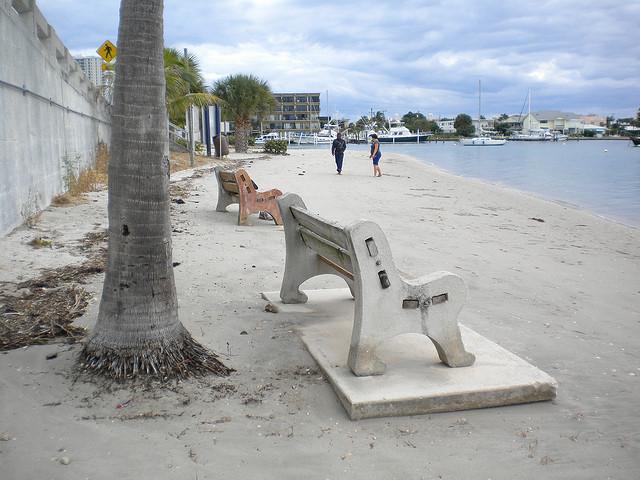Is there a television here?
Keep it brief. No. Is it a cold day?
Concise answer only. No. Can you see the roots of the tree?
Answer briefly. Yes. Are boats in this picture?
Short answer required. Yes. 